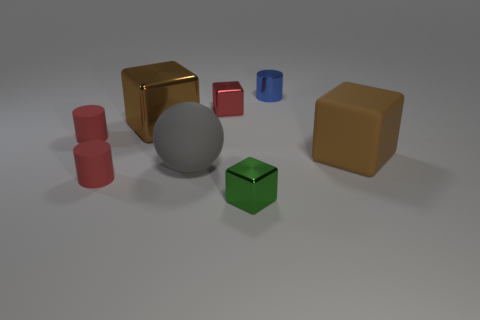Subtract 1 cubes. How many cubes are left? 3 Add 2 purple rubber cylinders. How many objects exist? 10 Subtract all spheres. How many objects are left? 7 Add 5 gray rubber cylinders. How many gray rubber cylinders exist? 5 Subtract 0 red balls. How many objects are left? 8 Subtract all brown rubber objects. Subtract all big matte spheres. How many objects are left? 6 Add 7 red shiny blocks. How many red shiny blocks are left? 8 